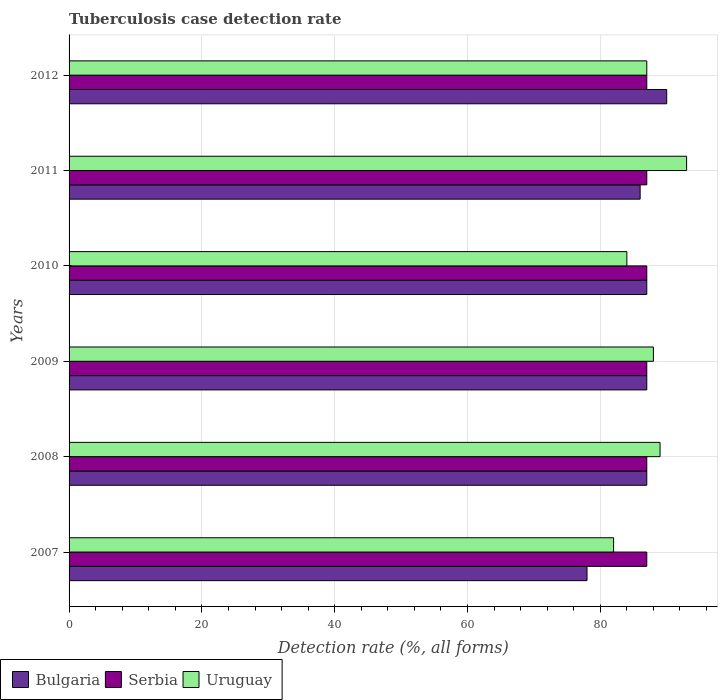How many different coloured bars are there?
Give a very brief answer. 3. How many groups of bars are there?
Provide a short and direct response. 6. Are the number of bars on each tick of the Y-axis equal?
Your response must be concise. Yes. How many bars are there on the 5th tick from the top?
Offer a terse response. 3. What is the label of the 5th group of bars from the top?
Your answer should be very brief. 2008. What is the tuberculosis case detection rate in in Bulgaria in 2011?
Provide a short and direct response. 86. Across all years, what is the maximum tuberculosis case detection rate in in Bulgaria?
Provide a succinct answer. 90. Across all years, what is the minimum tuberculosis case detection rate in in Uruguay?
Make the answer very short. 82. In which year was the tuberculosis case detection rate in in Uruguay minimum?
Give a very brief answer. 2007. What is the total tuberculosis case detection rate in in Uruguay in the graph?
Offer a very short reply. 523. What is the difference between the tuberculosis case detection rate in in Bulgaria in 2011 and the tuberculosis case detection rate in in Uruguay in 2008?
Offer a very short reply. -3. What is the average tuberculosis case detection rate in in Serbia per year?
Your answer should be compact. 87. In the year 2011, what is the difference between the tuberculosis case detection rate in in Bulgaria and tuberculosis case detection rate in in Uruguay?
Offer a terse response. -7. Is the difference between the tuberculosis case detection rate in in Bulgaria in 2007 and 2011 greater than the difference between the tuberculosis case detection rate in in Uruguay in 2007 and 2011?
Ensure brevity in your answer.  Yes. What is the difference between the highest and the lowest tuberculosis case detection rate in in Bulgaria?
Keep it short and to the point. 12. Is the sum of the tuberculosis case detection rate in in Uruguay in 2007 and 2012 greater than the maximum tuberculosis case detection rate in in Serbia across all years?
Provide a short and direct response. Yes. How many bars are there?
Offer a terse response. 18. Are all the bars in the graph horizontal?
Offer a very short reply. Yes. How many years are there in the graph?
Ensure brevity in your answer.  6. Does the graph contain grids?
Your response must be concise. Yes. Where does the legend appear in the graph?
Ensure brevity in your answer.  Bottom left. What is the title of the graph?
Keep it short and to the point. Tuberculosis case detection rate. Does "Faeroe Islands" appear as one of the legend labels in the graph?
Your response must be concise. No. What is the label or title of the X-axis?
Keep it short and to the point. Detection rate (%, all forms). What is the label or title of the Y-axis?
Ensure brevity in your answer.  Years. What is the Detection rate (%, all forms) in Serbia in 2007?
Offer a terse response. 87. What is the Detection rate (%, all forms) of Uruguay in 2007?
Ensure brevity in your answer.  82. What is the Detection rate (%, all forms) of Uruguay in 2008?
Make the answer very short. 89. What is the Detection rate (%, all forms) of Uruguay in 2009?
Provide a short and direct response. 88. What is the Detection rate (%, all forms) of Bulgaria in 2010?
Your response must be concise. 87. What is the Detection rate (%, all forms) in Serbia in 2010?
Keep it short and to the point. 87. What is the Detection rate (%, all forms) in Uruguay in 2011?
Make the answer very short. 93. What is the Detection rate (%, all forms) in Bulgaria in 2012?
Provide a succinct answer. 90. Across all years, what is the maximum Detection rate (%, all forms) of Bulgaria?
Ensure brevity in your answer.  90. Across all years, what is the maximum Detection rate (%, all forms) of Serbia?
Offer a very short reply. 87. Across all years, what is the maximum Detection rate (%, all forms) in Uruguay?
Your answer should be compact. 93. Across all years, what is the minimum Detection rate (%, all forms) in Bulgaria?
Your response must be concise. 78. Across all years, what is the minimum Detection rate (%, all forms) in Uruguay?
Provide a short and direct response. 82. What is the total Detection rate (%, all forms) in Bulgaria in the graph?
Make the answer very short. 515. What is the total Detection rate (%, all forms) of Serbia in the graph?
Provide a short and direct response. 522. What is the total Detection rate (%, all forms) in Uruguay in the graph?
Make the answer very short. 523. What is the difference between the Detection rate (%, all forms) of Bulgaria in 2007 and that in 2008?
Keep it short and to the point. -9. What is the difference between the Detection rate (%, all forms) in Serbia in 2007 and that in 2008?
Ensure brevity in your answer.  0. What is the difference between the Detection rate (%, all forms) in Uruguay in 2007 and that in 2008?
Ensure brevity in your answer.  -7. What is the difference between the Detection rate (%, all forms) in Bulgaria in 2007 and that in 2009?
Ensure brevity in your answer.  -9. What is the difference between the Detection rate (%, all forms) in Serbia in 2007 and that in 2009?
Offer a terse response. 0. What is the difference between the Detection rate (%, all forms) of Bulgaria in 2007 and that in 2010?
Offer a terse response. -9. What is the difference between the Detection rate (%, all forms) in Serbia in 2007 and that in 2010?
Your answer should be compact. 0. What is the difference between the Detection rate (%, all forms) of Bulgaria in 2007 and that in 2011?
Your answer should be compact. -8. What is the difference between the Detection rate (%, all forms) of Serbia in 2007 and that in 2011?
Your answer should be compact. 0. What is the difference between the Detection rate (%, all forms) in Uruguay in 2007 and that in 2011?
Your response must be concise. -11. What is the difference between the Detection rate (%, all forms) of Bulgaria in 2007 and that in 2012?
Give a very brief answer. -12. What is the difference between the Detection rate (%, all forms) in Serbia in 2007 and that in 2012?
Ensure brevity in your answer.  0. What is the difference between the Detection rate (%, all forms) in Serbia in 2008 and that in 2009?
Offer a very short reply. 0. What is the difference between the Detection rate (%, all forms) in Serbia in 2008 and that in 2010?
Provide a succinct answer. 0. What is the difference between the Detection rate (%, all forms) of Uruguay in 2008 and that in 2010?
Provide a short and direct response. 5. What is the difference between the Detection rate (%, all forms) in Serbia in 2008 and that in 2011?
Make the answer very short. 0. What is the difference between the Detection rate (%, all forms) in Uruguay in 2008 and that in 2011?
Your response must be concise. -4. What is the difference between the Detection rate (%, all forms) in Bulgaria in 2008 and that in 2012?
Keep it short and to the point. -3. What is the difference between the Detection rate (%, all forms) in Uruguay in 2008 and that in 2012?
Make the answer very short. 2. What is the difference between the Detection rate (%, all forms) of Bulgaria in 2009 and that in 2010?
Provide a succinct answer. 0. What is the difference between the Detection rate (%, all forms) in Serbia in 2009 and that in 2010?
Offer a very short reply. 0. What is the difference between the Detection rate (%, all forms) of Bulgaria in 2009 and that in 2011?
Keep it short and to the point. 1. What is the difference between the Detection rate (%, all forms) in Serbia in 2009 and that in 2011?
Give a very brief answer. 0. What is the difference between the Detection rate (%, all forms) of Serbia in 2009 and that in 2012?
Ensure brevity in your answer.  0. What is the difference between the Detection rate (%, all forms) in Uruguay in 2009 and that in 2012?
Ensure brevity in your answer.  1. What is the difference between the Detection rate (%, all forms) of Bulgaria in 2010 and that in 2011?
Your response must be concise. 1. What is the difference between the Detection rate (%, all forms) of Serbia in 2010 and that in 2011?
Give a very brief answer. 0. What is the difference between the Detection rate (%, all forms) in Uruguay in 2010 and that in 2011?
Give a very brief answer. -9. What is the difference between the Detection rate (%, all forms) of Bulgaria in 2010 and that in 2012?
Provide a short and direct response. -3. What is the difference between the Detection rate (%, all forms) in Serbia in 2010 and that in 2012?
Offer a very short reply. 0. What is the difference between the Detection rate (%, all forms) in Uruguay in 2011 and that in 2012?
Your answer should be very brief. 6. What is the difference between the Detection rate (%, all forms) of Bulgaria in 2007 and the Detection rate (%, all forms) of Uruguay in 2008?
Offer a terse response. -11. What is the difference between the Detection rate (%, all forms) of Serbia in 2007 and the Detection rate (%, all forms) of Uruguay in 2008?
Ensure brevity in your answer.  -2. What is the difference between the Detection rate (%, all forms) in Bulgaria in 2007 and the Detection rate (%, all forms) in Serbia in 2009?
Make the answer very short. -9. What is the difference between the Detection rate (%, all forms) of Bulgaria in 2007 and the Detection rate (%, all forms) of Uruguay in 2009?
Ensure brevity in your answer.  -10. What is the difference between the Detection rate (%, all forms) of Bulgaria in 2007 and the Detection rate (%, all forms) of Serbia in 2012?
Give a very brief answer. -9. What is the difference between the Detection rate (%, all forms) in Bulgaria in 2008 and the Detection rate (%, all forms) in Serbia in 2010?
Your response must be concise. 0. What is the difference between the Detection rate (%, all forms) of Bulgaria in 2008 and the Detection rate (%, all forms) of Serbia in 2011?
Provide a short and direct response. 0. What is the difference between the Detection rate (%, all forms) in Serbia in 2008 and the Detection rate (%, all forms) in Uruguay in 2012?
Keep it short and to the point. 0. What is the difference between the Detection rate (%, all forms) in Bulgaria in 2009 and the Detection rate (%, all forms) in Uruguay in 2011?
Ensure brevity in your answer.  -6. What is the difference between the Detection rate (%, all forms) of Serbia in 2009 and the Detection rate (%, all forms) of Uruguay in 2011?
Offer a very short reply. -6. What is the difference between the Detection rate (%, all forms) of Bulgaria in 2009 and the Detection rate (%, all forms) of Uruguay in 2012?
Your response must be concise. 0. What is the difference between the Detection rate (%, all forms) in Serbia in 2009 and the Detection rate (%, all forms) in Uruguay in 2012?
Offer a terse response. 0. What is the difference between the Detection rate (%, all forms) in Bulgaria in 2010 and the Detection rate (%, all forms) in Uruguay in 2011?
Make the answer very short. -6. What is the difference between the Detection rate (%, all forms) of Serbia in 2010 and the Detection rate (%, all forms) of Uruguay in 2011?
Give a very brief answer. -6. What is the difference between the Detection rate (%, all forms) in Serbia in 2010 and the Detection rate (%, all forms) in Uruguay in 2012?
Your answer should be very brief. 0. What is the difference between the Detection rate (%, all forms) in Bulgaria in 2011 and the Detection rate (%, all forms) in Uruguay in 2012?
Your answer should be very brief. -1. What is the average Detection rate (%, all forms) in Bulgaria per year?
Keep it short and to the point. 85.83. What is the average Detection rate (%, all forms) of Uruguay per year?
Keep it short and to the point. 87.17. In the year 2007, what is the difference between the Detection rate (%, all forms) of Bulgaria and Detection rate (%, all forms) of Serbia?
Your answer should be very brief. -9. In the year 2008, what is the difference between the Detection rate (%, all forms) in Bulgaria and Detection rate (%, all forms) in Serbia?
Keep it short and to the point. 0. In the year 2008, what is the difference between the Detection rate (%, all forms) of Bulgaria and Detection rate (%, all forms) of Uruguay?
Your answer should be very brief. -2. In the year 2008, what is the difference between the Detection rate (%, all forms) of Serbia and Detection rate (%, all forms) of Uruguay?
Ensure brevity in your answer.  -2. In the year 2009, what is the difference between the Detection rate (%, all forms) in Bulgaria and Detection rate (%, all forms) in Serbia?
Ensure brevity in your answer.  0. In the year 2009, what is the difference between the Detection rate (%, all forms) of Bulgaria and Detection rate (%, all forms) of Uruguay?
Provide a short and direct response. -1. In the year 2009, what is the difference between the Detection rate (%, all forms) of Serbia and Detection rate (%, all forms) of Uruguay?
Offer a terse response. -1. In the year 2010, what is the difference between the Detection rate (%, all forms) in Bulgaria and Detection rate (%, all forms) in Uruguay?
Provide a succinct answer. 3. In the year 2011, what is the difference between the Detection rate (%, all forms) in Bulgaria and Detection rate (%, all forms) in Serbia?
Your answer should be very brief. -1. In the year 2011, what is the difference between the Detection rate (%, all forms) in Bulgaria and Detection rate (%, all forms) in Uruguay?
Ensure brevity in your answer.  -7. In the year 2011, what is the difference between the Detection rate (%, all forms) in Serbia and Detection rate (%, all forms) in Uruguay?
Ensure brevity in your answer.  -6. In the year 2012, what is the difference between the Detection rate (%, all forms) of Bulgaria and Detection rate (%, all forms) of Serbia?
Provide a succinct answer. 3. In the year 2012, what is the difference between the Detection rate (%, all forms) of Bulgaria and Detection rate (%, all forms) of Uruguay?
Offer a very short reply. 3. In the year 2012, what is the difference between the Detection rate (%, all forms) of Serbia and Detection rate (%, all forms) of Uruguay?
Keep it short and to the point. 0. What is the ratio of the Detection rate (%, all forms) in Bulgaria in 2007 to that in 2008?
Your answer should be very brief. 0.9. What is the ratio of the Detection rate (%, all forms) of Uruguay in 2007 to that in 2008?
Your answer should be very brief. 0.92. What is the ratio of the Detection rate (%, all forms) in Bulgaria in 2007 to that in 2009?
Offer a terse response. 0.9. What is the ratio of the Detection rate (%, all forms) in Serbia in 2007 to that in 2009?
Ensure brevity in your answer.  1. What is the ratio of the Detection rate (%, all forms) of Uruguay in 2007 to that in 2009?
Your answer should be compact. 0.93. What is the ratio of the Detection rate (%, all forms) of Bulgaria in 2007 to that in 2010?
Give a very brief answer. 0.9. What is the ratio of the Detection rate (%, all forms) in Uruguay in 2007 to that in 2010?
Ensure brevity in your answer.  0.98. What is the ratio of the Detection rate (%, all forms) of Bulgaria in 2007 to that in 2011?
Provide a succinct answer. 0.91. What is the ratio of the Detection rate (%, all forms) in Uruguay in 2007 to that in 2011?
Give a very brief answer. 0.88. What is the ratio of the Detection rate (%, all forms) of Bulgaria in 2007 to that in 2012?
Make the answer very short. 0.87. What is the ratio of the Detection rate (%, all forms) of Serbia in 2007 to that in 2012?
Your answer should be very brief. 1. What is the ratio of the Detection rate (%, all forms) in Uruguay in 2007 to that in 2012?
Provide a short and direct response. 0.94. What is the ratio of the Detection rate (%, all forms) in Serbia in 2008 to that in 2009?
Make the answer very short. 1. What is the ratio of the Detection rate (%, all forms) in Uruguay in 2008 to that in 2009?
Ensure brevity in your answer.  1.01. What is the ratio of the Detection rate (%, all forms) in Uruguay in 2008 to that in 2010?
Keep it short and to the point. 1.06. What is the ratio of the Detection rate (%, all forms) of Bulgaria in 2008 to that in 2011?
Ensure brevity in your answer.  1.01. What is the ratio of the Detection rate (%, all forms) of Serbia in 2008 to that in 2011?
Offer a terse response. 1. What is the ratio of the Detection rate (%, all forms) of Bulgaria in 2008 to that in 2012?
Offer a very short reply. 0.97. What is the ratio of the Detection rate (%, all forms) in Serbia in 2008 to that in 2012?
Your answer should be very brief. 1. What is the ratio of the Detection rate (%, all forms) in Bulgaria in 2009 to that in 2010?
Give a very brief answer. 1. What is the ratio of the Detection rate (%, all forms) in Uruguay in 2009 to that in 2010?
Provide a succinct answer. 1.05. What is the ratio of the Detection rate (%, all forms) in Bulgaria in 2009 to that in 2011?
Ensure brevity in your answer.  1.01. What is the ratio of the Detection rate (%, all forms) of Serbia in 2009 to that in 2011?
Your answer should be very brief. 1. What is the ratio of the Detection rate (%, all forms) of Uruguay in 2009 to that in 2011?
Provide a succinct answer. 0.95. What is the ratio of the Detection rate (%, all forms) in Bulgaria in 2009 to that in 2012?
Offer a very short reply. 0.97. What is the ratio of the Detection rate (%, all forms) of Serbia in 2009 to that in 2012?
Provide a succinct answer. 1. What is the ratio of the Detection rate (%, all forms) of Uruguay in 2009 to that in 2012?
Offer a very short reply. 1.01. What is the ratio of the Detection rate (%, all forms) of Bulgaria in 2010 to that in 2011?
Keep it short and to the point. 1.01. What is the ratio of the Detection rate (%, all forms) of Uruguay in 2010 to that in 2011?
Keep it short and to the point. 0.9. What is the ratio of the Detection rate (%, all forms) in Bulgaria in 2010 to that in 2012?
Give a very brief answer. 0.97. What is the ratio of the Detection rate (%, all forms) of Serbia in 2010 to that in 2012?
Offer a terse response. 1. What is the ratio of the Detection rate (%, all forms) of Uruguay in 2010 to that in 2012?
Offer a very short reply. 0.97. What is the ratio of the Detection rate (%, all forms) in Bulgaria in 2011 to that in 2012?
Make the answer very short. 0.96. What is the ratio of the Detection rate (%, all forms) of Uruguay in 2011 to that in 2012?
Give a very brief answer. 1.07. What is the difference between the highest and the second highest Detection rate (%, all forms) of Bulgaria?
Make the answer very short. 3. What is the difference between the highest and the second highest Detection rate (%, all forms) in Serbia?
Your answer should be compact. 0. What is the difference between the highest and the lowest Detection rate (%, all forms) of Bulgaria?
Your answer should be very brief. 12. What is the difference between the highest and the lowest Detection rate (%, all forms) in Serbia?
Offer a very short reply. 0. What is the difference between the highest and the lowest Detection rate (%, all forms) in Uruguay?
Ensure brevity in your answer.  11. 